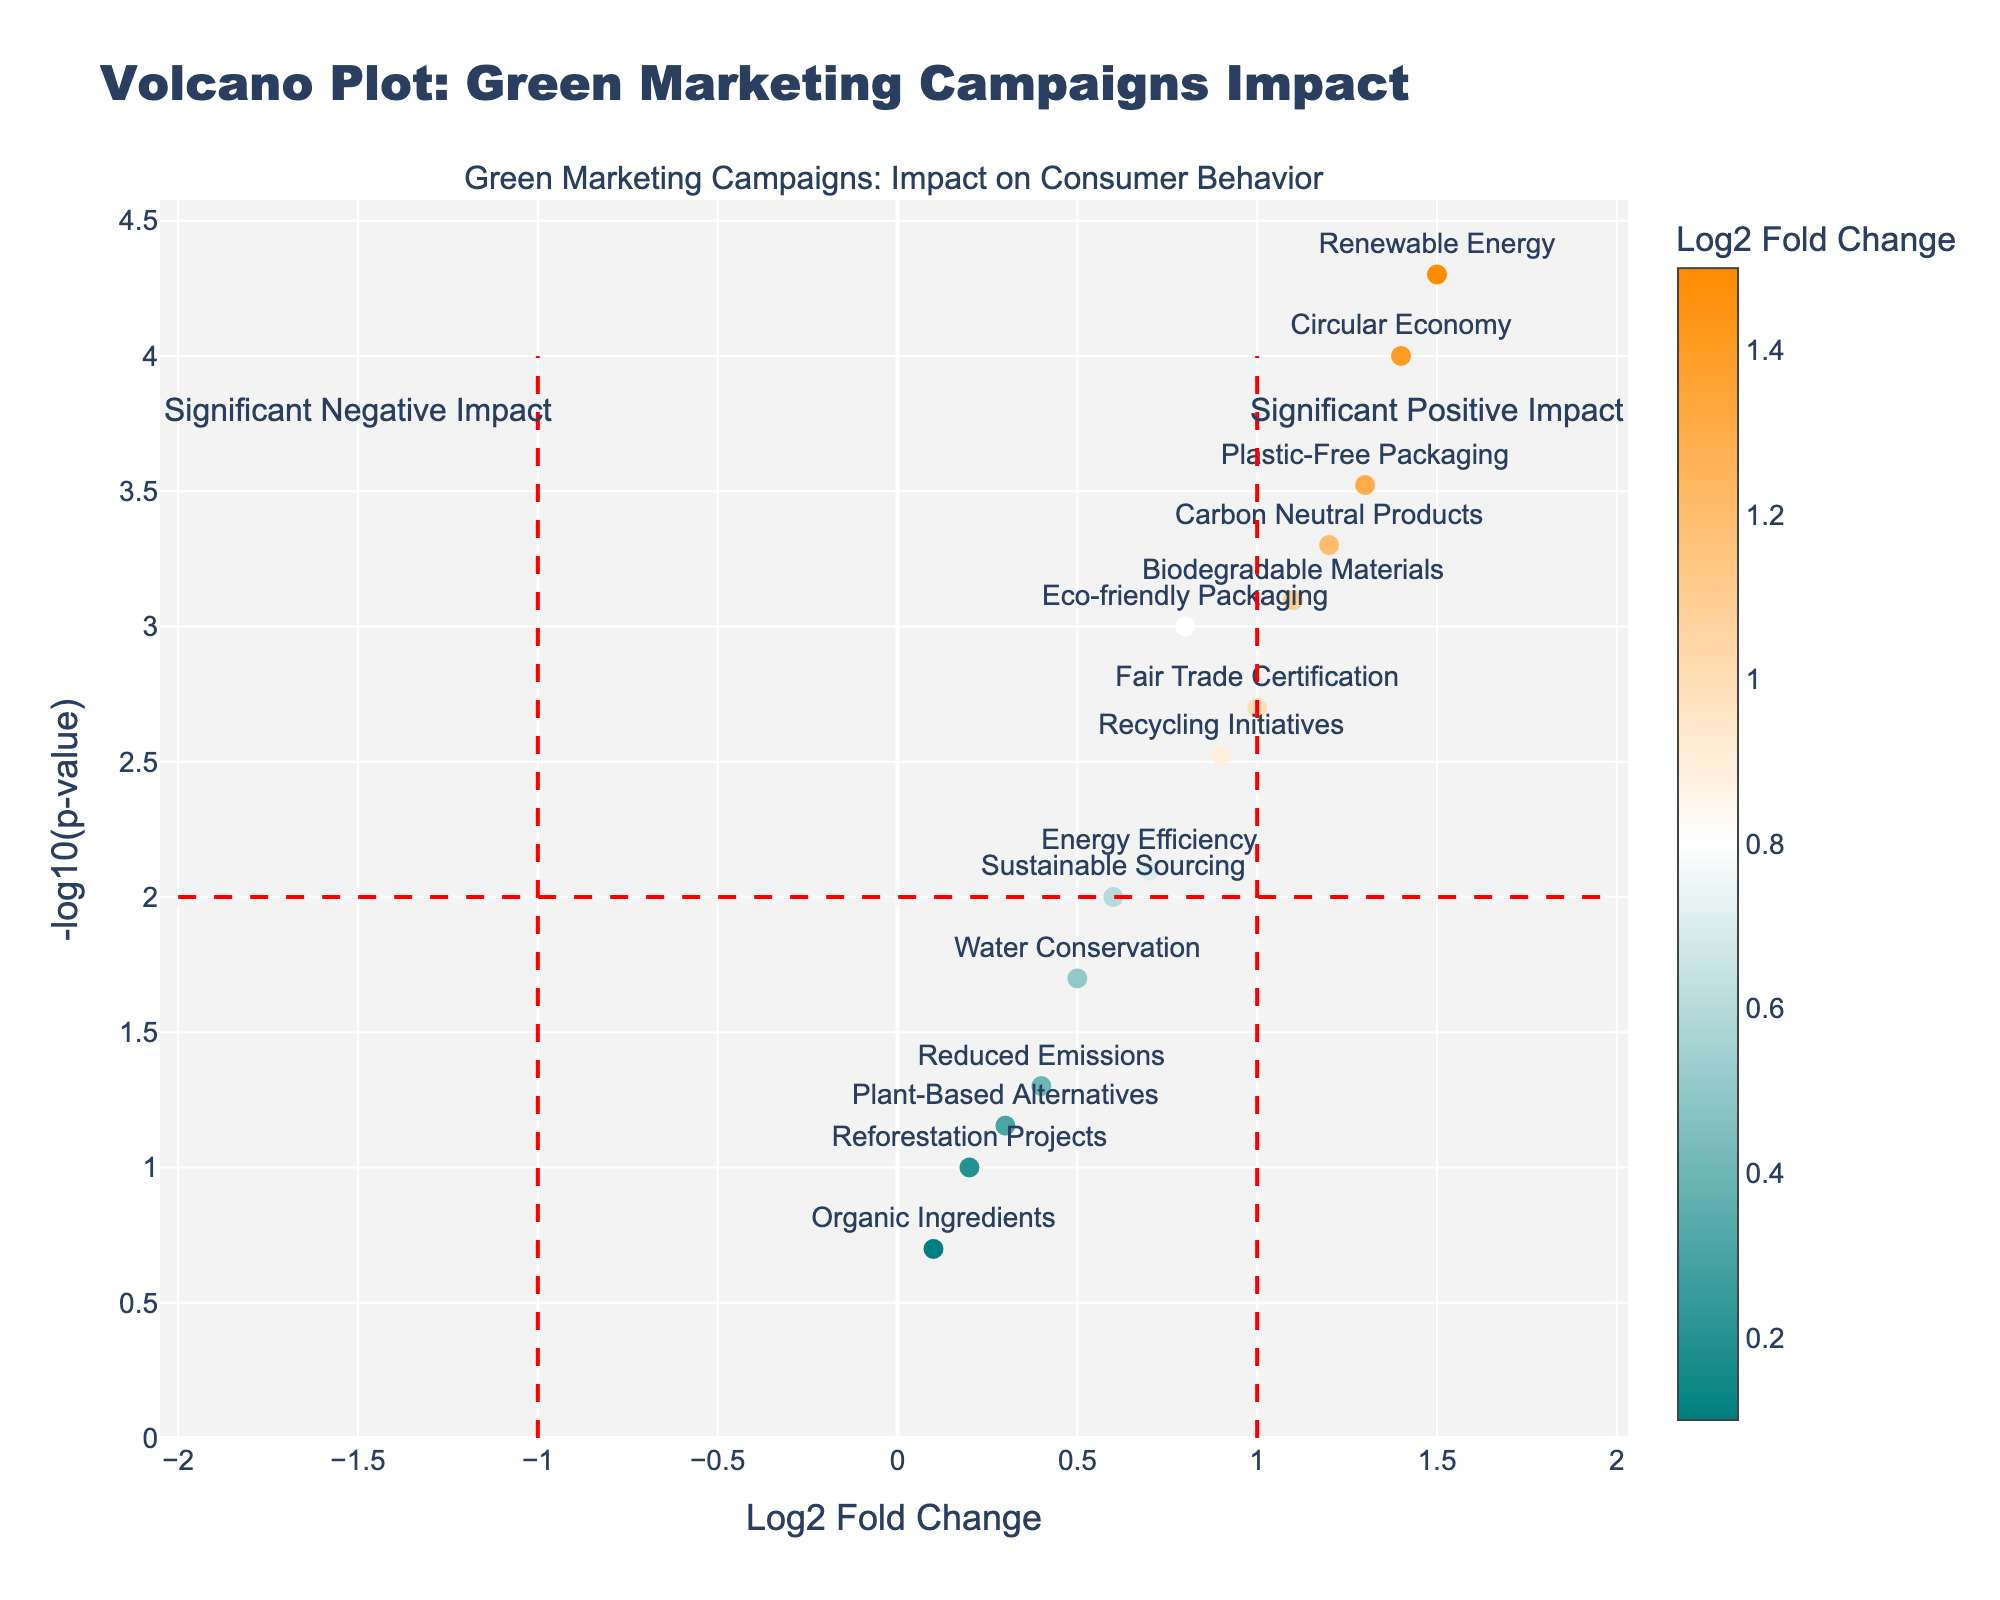How many campaigns show a significant positive impact? A significant positive impact is indicated by points with -log10(p-value) > 2 and Log2 Fold Change > 1. By observing the plot, there are 6 such data points visible.
Answer: 6 Which campaign in the Denmark market shows the highest positive impact? By looking at the plot, the Denmark market data point has the highest Log2 Fold Change above the threshold and the highest -log10(p-value). The campaign is 'Renewable Energy'.
Answer: Renewable Energy What is the Log2 Fold Change range of campaigns in markets that show a significant positive impact? Significant positive impacts are noted where the -log10(p-value) > 2 and Log2 Fold Change > 1. By observing the x-axis, the Log2 Fold Change ranges from 1.1 to 1.5.
Answer: 1.1 to 1.5 Which market has the least significant impact from its green marketing campaign? A less significant impact is indicated by higher p-value (lower -log10(p-value)). The point with the lowest -log10(p-value) corresponds to a campaign in South Korea with 'Organic Ingredients'.
Answer: South Korea What campaign has a Log2 Fold Change of 1.2, and how significant is its impact? When checking the plot, the campaign with Log2 Fold Change of 1.2 is 'Carbon Neutral Products' in Germany. It has a significant impact indicated by a high -log10(p-value) value.
Answer: Carbon Neutral Products in Germany; significant impact How many campaigns are below the significance threshold on the y-axis? The significance threshold on the y-axis is -log10(p-value) > 2. There are 4 data points below this line.
Answer: 4 Which campaigns fall just above the threshold for Log2 Fold Change on the positive side? The campaigns just above the Log2 Fold Change threshold (> 1) are 'Biodegradable Materials' (Canada) and 'Fair Trade Certification' (Sweden).
Answer: Biodegradable Materials and Fair Trade Certification Is there a campaign in the Brazilian market, and what is its impact? By looking at the plot, the Brazilian market has a campaign, 'Reforestation Projects,' with a Log2 Fold Change of 0.2 and -log10(p-value) < 2, indicating an insignificant positive impact.
Answer: Reforestation Projects; insignificant How does the impact of 'Plastic-Free Packaging' in Italy compare to 'Eco-friendly Packaging' in the US? 'Plastic-Free Packaging' in Italy has a Log2 Fold Change of 1.3 with a highly significant -log10(p-value), while 'Eco-friendly Packaging' in the US has a Log2 Fold Change of 0.8 with a -log10(p-value) around 3. Plastic-Free Packaging has a higher impact.
Answer: Plastic-Free Packaging has a higher impact 